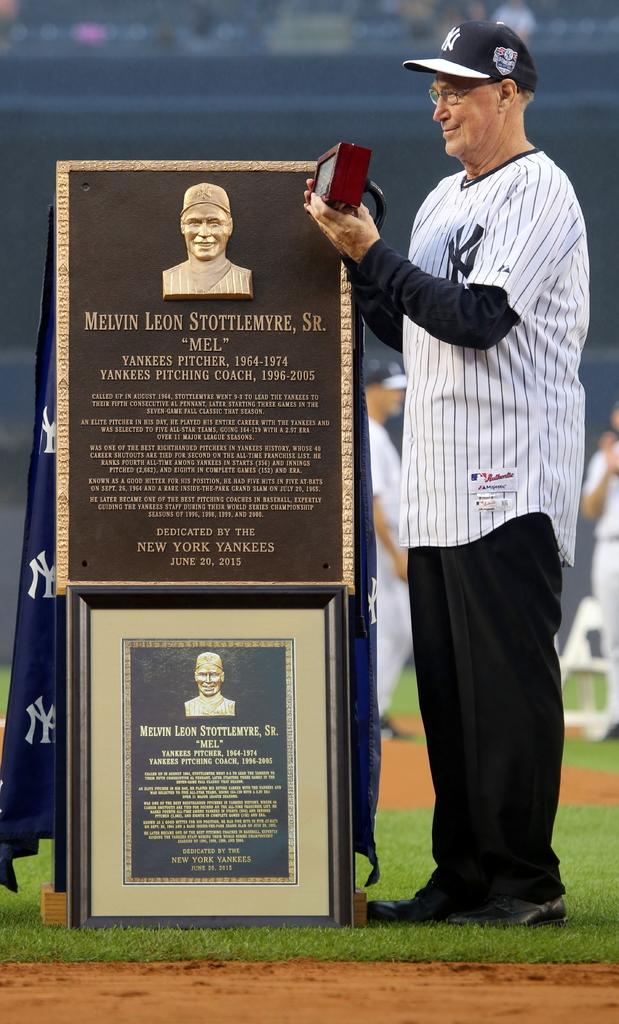<image>
Summarize the visual content of the image. A baseball player with the Melvin Leon Stottlemye plaque. 